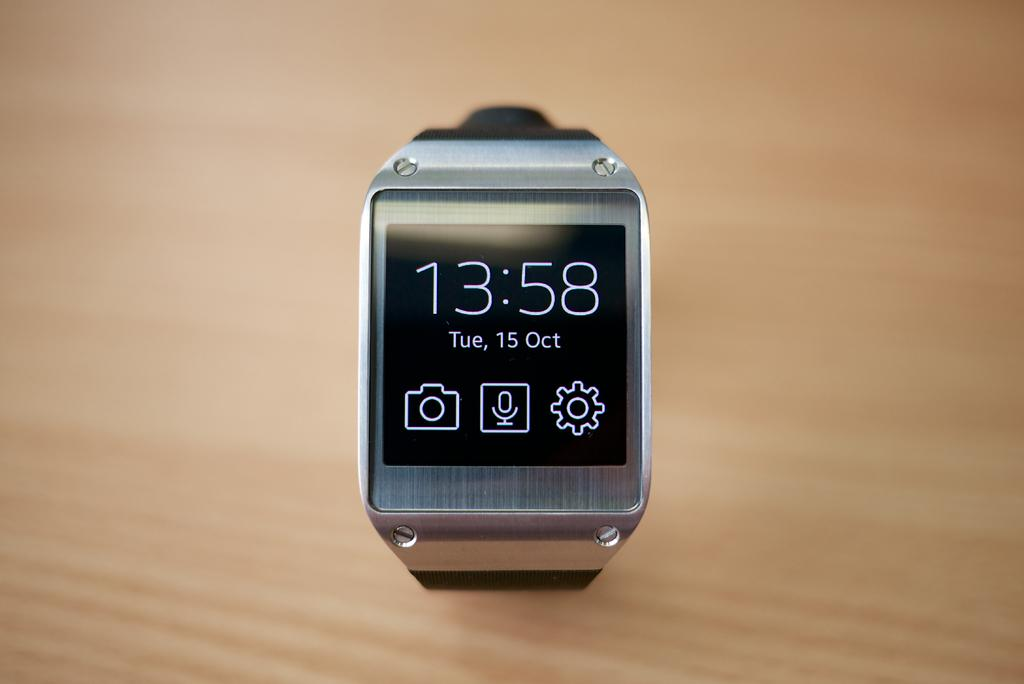<image>
Relay a brief, clear account of the picture shown. Square watch which says the time is 13:58. 